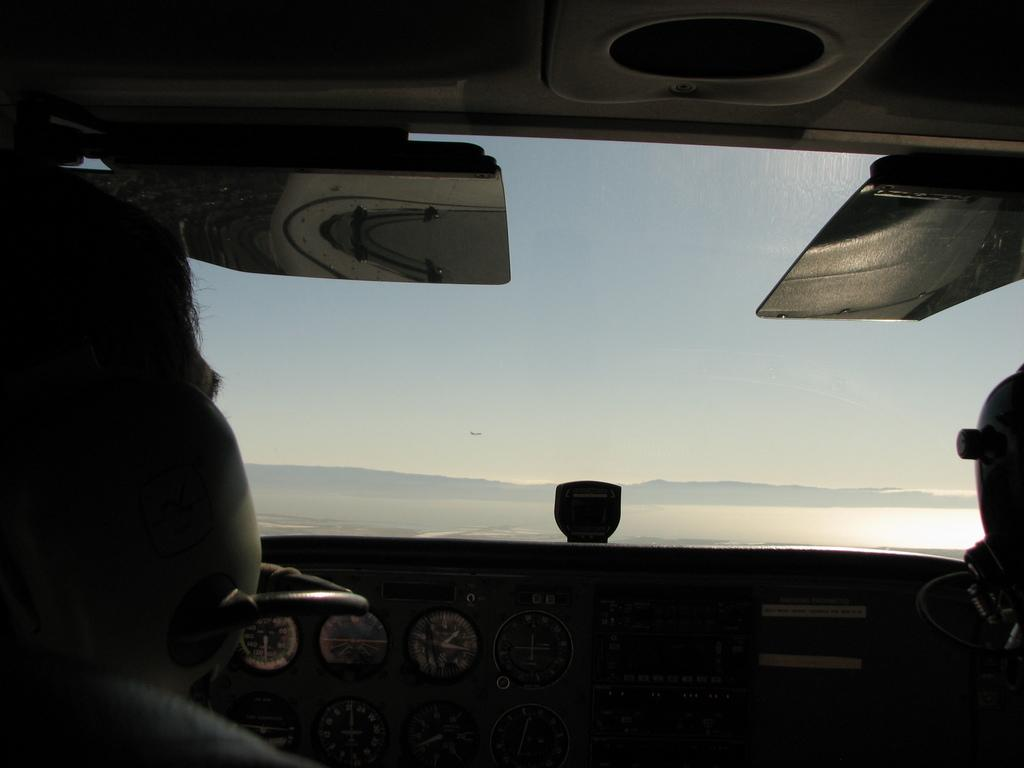What type of animals can be seen in the image? There are cows, sheep, and horses in the image. Are there any other animals present in the image? No, the image only shows cows, sheep, and horses. What type of hat is the cow wearing in the image? There is no hat present on the cow in the image. How many books can be seen on the table in the image? There is no table or books present in the image; it only shows animals. 